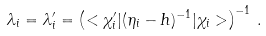Convert formula to latex. <formula><loc_0><loc_0><loc_500><loc_500>\lambda _ { i } = \lambda ^ { \prime } _ { i } = \left ( < \chi ^ { \prime } _ { i } | ( \eta _ { i } - h ) ^ { - 1 } | \chi _ { i } > \right ) ^ { - 1 } \, .</formula> 